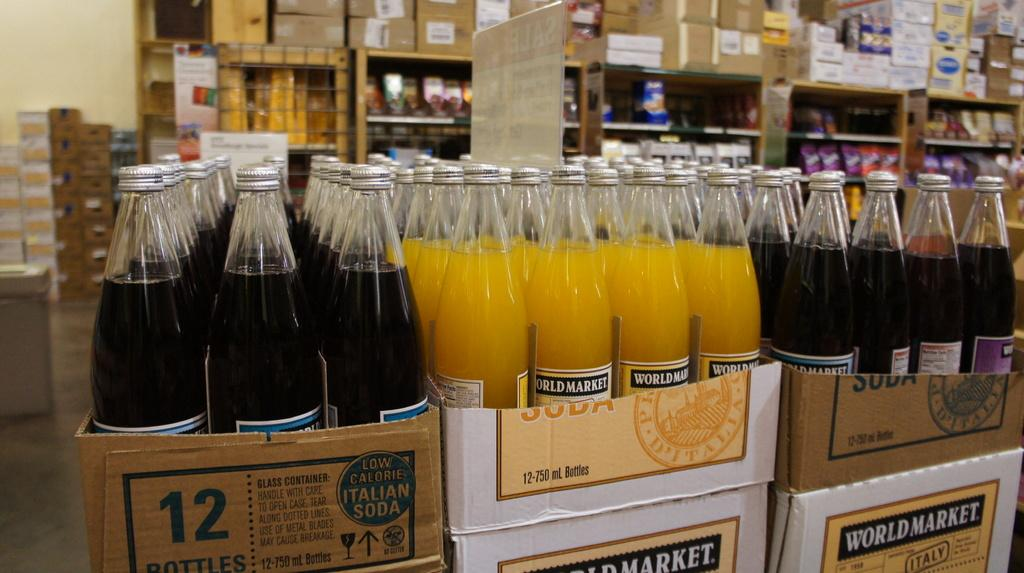<image>
Offer a succinct explanation of the picture presented. A display of beverages features World Market products. 